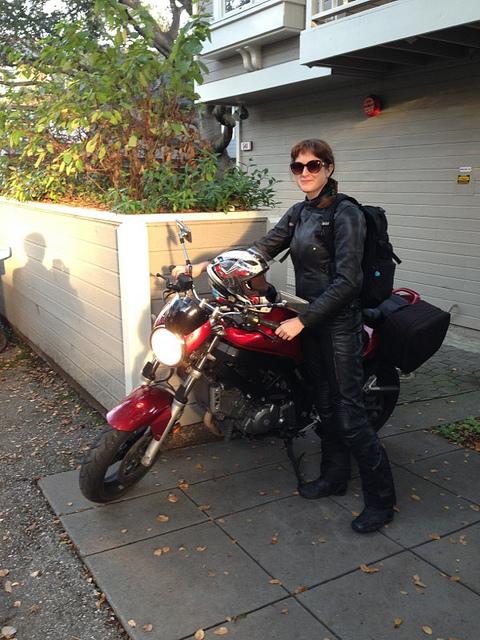Is this vehicle capable of fast speed?
Short answer required. Yes. Is the photographer somewhat visible?
Quick response, please. Yes. Is this woman licensed to ride a motorcycle?
Concise answer only. Yes. Is this woman dressed to ride a bike?
Answer briefly. Yes. 